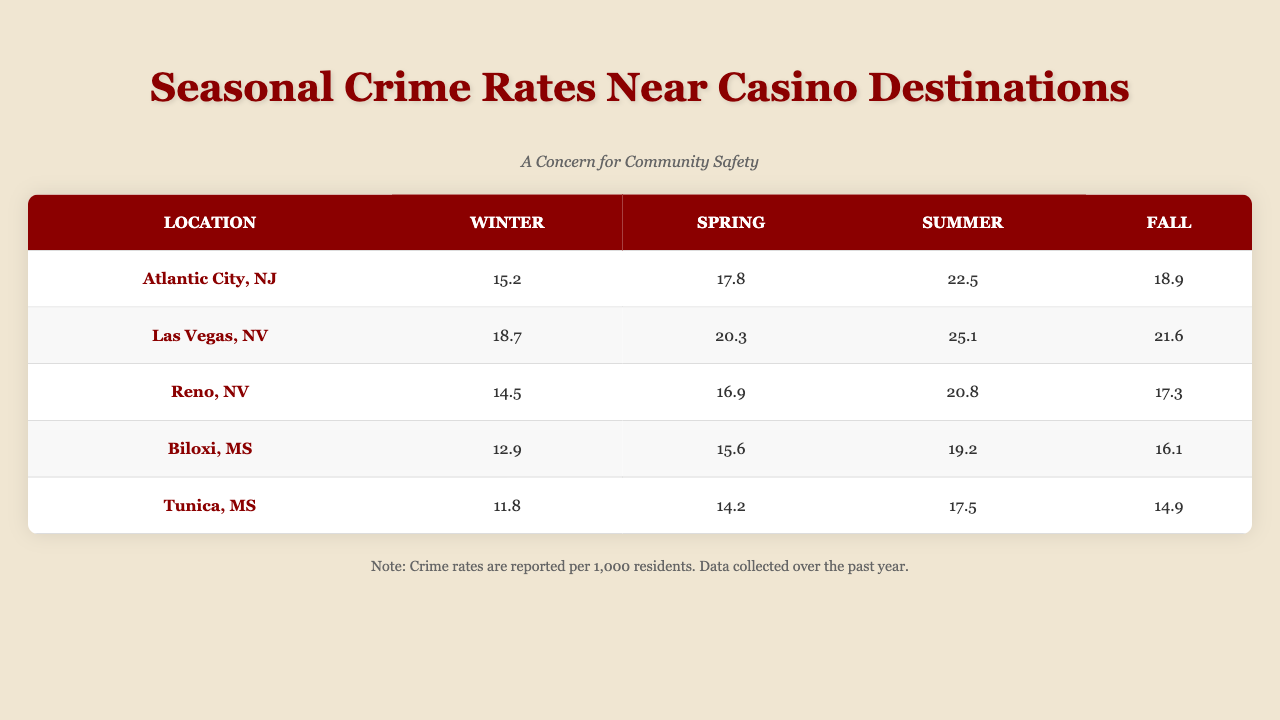What is the highest crime rate recorded in Atlantic City during the summer? The crime rate for Atlantic City in the summer is 22.5, which is the highest among the seasonal rates listed for this location.
Answer: 22.5 What is the crime rate in Biloxi during the fall? The crime rate for Biloxi in the fall is 16.1, as indicated in the table.
Answer: 16.1 Which location has the lowest winter crime rate? By comparing the winter crime rates, we find that Tunica, MS has the lowest at 11.8 per 1,000 residents, compared to the others.
Answer: Tunica, MS What is the average crime rate for summer across all locations? To find the average, sum the summer crime rates: (22.5 + 25.1 + 20.8 + 19.2 + 17.5) = 105.1. Then divide by 5: 105.1 / 5 = 21.02.
Answer: 21.02 Is the spring crime rate in Reno higher than that in Tunica? The spring crime rate in Reno is 16.9, while in Tunica, it is 14.2. Since 16.9 > 14.2, the statement is true.
Answer: Yes What is the difference between the highest and lowest summer crime rates? The highest summer crime rate is 25.1 (Las Vegas), and the lowest is 17.5 (Tunica). The difference is 25.1 - 17.5 = 7.6.
Answer: 7.6 In which season does Atlantic City show a crime rate increase of more than 10%? Atlantic City shows a percentage increase greater than 10% in spring (12.3%), summer (18.7%), and fall (10.2%). Therefore, it is true for those three seasons.
Answer: Spring, Summer, Fall What is the overall trend for crime rates across all seasons for Las Vegas? The crime rates for Las Vegas are 18.7 in winter, 20.3 in spring, 25.1 in summer, and 21.6 in fall. The trend shows an increase from winter to summer and then a slight decrease in fall.
Answer: Increasing then slight decrease What’s the total tourist influx in Reno across all seasons? Summing the tourist influx in Reno: 600000 + 900000 + 1400000 + 750000 = 3650000.
Answer: 3650000 Which location shows the smallest increase in crime rates during spring? The percentage increase in crime rates during spring is smallest for Tunica at 8.5%.
Answer: Tunica 